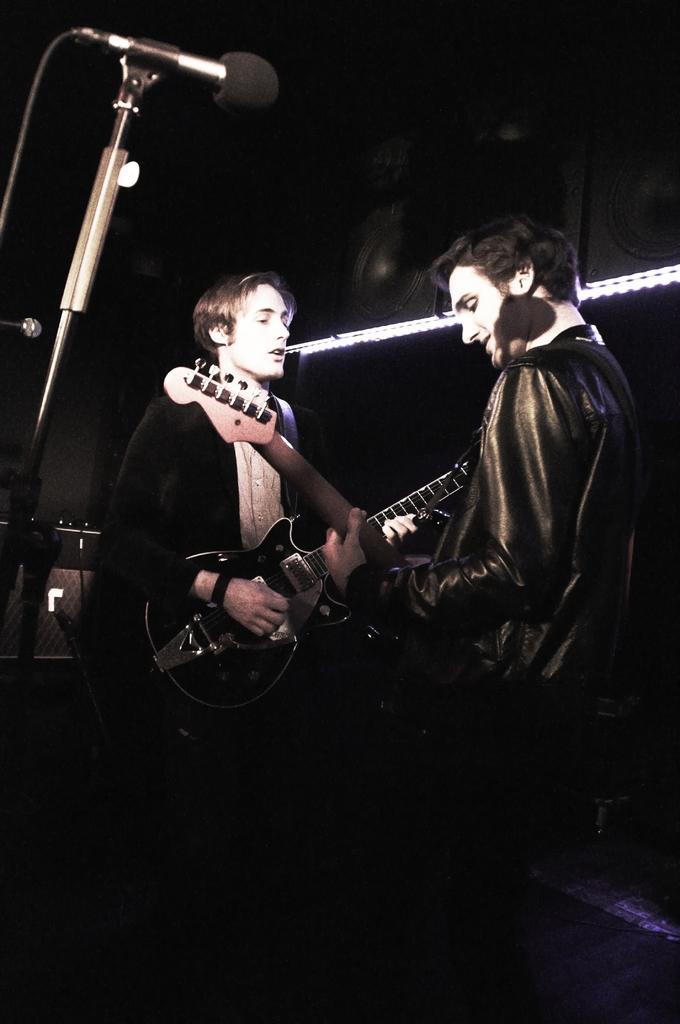Please provide a concise description of this image. These two persons are playing guitar in-front of mic. On top there is a speaker and light. 